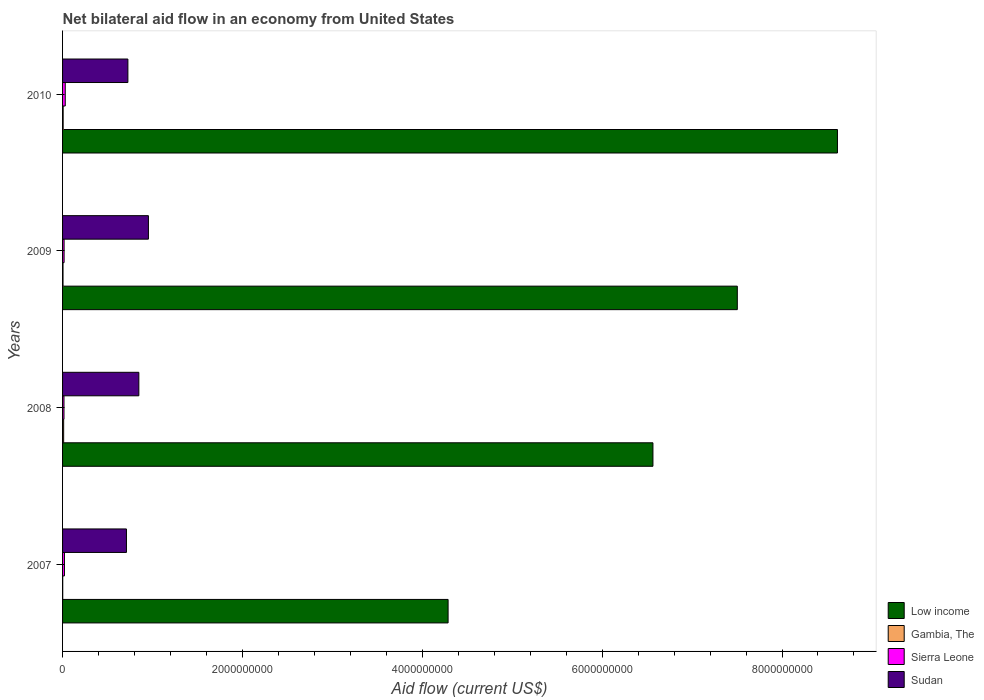Are the number of bars on each tick of the Y-axis equal?
Make the answer very short. Yes. What is the net bilateral aid flow in Sierra Leone in 2008?
Make the answer very short. 1.58e+07. Across all years, what is the maximum net bilateral aid flow in Sierra Leone?
Your answer should be very brief. 2.98e+07. Across all years, what is the minimum net bilateral aid flow in Gambia, The?
Make the answer very short. 1.66e+06. In which year was the net bilateral aid flow in Sierra Leone minimum?
Your response must be concise. 2008. What is the total net bilateral aid flow in Gambia, The in the graph?
Keep it short and to the point. 2.51e+07. What is the difference between the net bilateral aid flow in Gambia, The in 2008 and that in 2010?
Ensure brevity in your answer.  5.55e+06. What is the difference between the net bilateral aid flow in Low income in 2010 and the net bilateral aid flow in Sierra Leone in 2007?
Provide a short and direct response. 8.60e+09. What is the average net bilateral aid flow in Low income per year?
Offer a very short reply. 6.74e+09. In the year 2007, what is the difference between the net bilateral aid flow in Sierra Leone and net bilateral aid flow in Low income?
Your response must be concise. -4.27e+09. In how many years, is the net bilateral aid flow in Gambia, The greater than 6400000000 US$?
Your answer should be compact. 0. What is the ratio of the net bilateral aid flow in Sierra Leone in 2008 to that in 2010?
Make the answer very short. 0.53. Is the net bilateral aid flow in Low income in 2007 less than that in 2010?
Make the answer very short. Yes. Is the difference between the net bilateral aid flow in Sierra Leone in 2008 and 2009 greater than the difference between the net bilateral aid flow in Low income in 2008 and 2009?
Offer a very short reply. Yes. What is the difference between the highest and the second highest net bilateral aid flow in Sudan?
Keep it short and to the point. 1.06e+08. What is the difference between the highest and the lowest net bilateral aid flow in Sierra Leone?
Provide a short and direct response. 1.40e+07. In how many years, is the net bilateral aid flow in Low income greater than the average net bilateral aid flow in Low income taken over all years?
Ensure brevity in your answer.  2. Is the sum of the net bilateral aid flow in Gambia, The in 2007 and 2009 greater than the maximum net bilateral aid flow in Sierra Leone across all years?
Your response must be concise. No. What does the 3rd bar from the top in 2010 represents?
Your answer should be compact. Gambia, The. How many years are there in the graph?
Your answer should be compact. 4. What is the difference between two consecutive major ticks on the X-axis?
Provide a succinct answer. 2.00e+09. Are the values on the major ticks of X-axis written in scientific E-notation?
Make the answer very short. No. Does the graph contain any zero values?
Ensure brevity in your answer.  No. How are the legend labels stacked?
Provide a succinct answer. Vertical. What is the title of the graph?
Your response must be concise. Net bilateral aid flow in an economy from United States. What is the Aid flow (current US$) of Low income in 2007?
Provide a short and direct response. 4.29e+09. What is the Aid flow (current US$) of Gambia, The in 2007?
Give a very brief answer. 1.66e+06. What is the Aid flow (current US$) in Sierra Leone in 2007?
Give a very brief answer. 2.09e+07. What is the Aid flow (current US$) in Sudan in 2007?
Offer a terse response. 7.10e+08. What is the Aid flow (current US$) in Low income in 2008?
Offer a very short reply. 6.56e+09. What is the Aid flow (current US$) in Gambia, The in 2008?
Make the answer very short. 1.20e+07. What is the Aid flow (current US$) in Sierra Leone in 2008?
Your answer should be very brief. 1.58e+07. What is the Aid flow (current US$) in Sudan in 2008?
Provide a succinct answer. 8.48e+08. What is the Aid flow (current US$) of Low income in 2009?
Ensure brevity in your answer.  7.50e+09. What is the Aid flow (current US$) of Gambia, The in 2009?
Offer a terse response. 4.95e+06. What is the Aid flow (current US$) of Sierra Leone in 2009?
Ensure brevity in your answer.  1.70e+07. What is the Aid flow (current US$) of Sudan in 2009?
Provide a short and direct response. 9.55e+08. What is the Aid flow (current US$) in Low income in 2010?
Your response must be concise. 8.62e+09. What is the Aid flow (current US$) of Gambia, The in 2010?
Ensure brevity in your answer.  6.49e+06. What is the Aid flow (current US$) of Sierra Leone in 2010?
Provide a short and direct response. 2.98e+07. What is the Aid flow (current US$) of Sudan in 2010?
Offer a very short reply. 7.26e+08. Across all years, what is the maximum Aid flow (current US$) in Low income?
Provide a short and direct response. 8.62e+09. Across all years, what is the maximum Aid flow (current US$) in Gambia, The?
Keep it short and to the point. 1.20e+07. Across all years, what is the maximum Aid flow (current US$) of Sierra Leone?
Your response must be concise. 2.98e+07. Across all years, what is the maximum Aid flow (current US$) in Sudan?
Offer a very short reply. 9.55e+08. Across all years, what is the minimum Aid flow (current US$) of Low income?
Your answer should be very brief. 4.29e+09. Across all years, what is the minimum Aid flow (current US$) in Gambia, The?
Ensure brevity in your answer.  1.66e+06. Across all years, what is the minimum Aid flow (current US$) of Sierra Leone?
Make the answer very short. 1.58e+07. Across all years, what is the minimum Aid flow (current US$) in Sudan?
Your answer should be very brief. 7.10e+08. What is the total Aid flow (current US$) in Low income in the graph?
Ensure brevity in your answer.  2.70e+1. What is the total Aid flow (current US$) in Gambia, The in the graph?
Offer a terse response. 2.51e+07. What is the total Aid flow (current US$) of Sierra Leone in the graph?
Keep it short and to the point. 8.35e+07. What is the total Aid flow (current US$) of Sudan in the graph?
Give a very brief answer. 3.24e+09. What is the difference between the Aid flow (current US$) in Low income in 2007 and that in 2008?
Give a very brief answer. -2.28e+09. What is the difference between the Aid flow (current US$) in Gambia, The in 2007 and that in 2008?
Keep it short and to the point. -1.04e+07. What is the difference between the Aid flow (current US$) in Sierra Leone in 2007 and that in 2008?
Offer a very short reply. 5.12e+06. What is the difference between the Aid flow (current US$) in Sudan in 2007 and that in 2008?
Your answer should be very brief. -1.38e+08. What is the difference between the Aid flow (current US$) in Low income in 2007 and that in 2009?
Give a very brief answer. -3.22e+09. What is the difference between the Aid flow (current US$) in Gambia, The in 2007 and that in 2009?
Give a very brief answer. -3.29e+06. What is the difference between the Aid flow (current US$) in Sierra Leone in 2007 and that in 2009?
Provide a short and direct response. 3.91e+06. What is the difference between the Aid flow (current US$) in Sudan in 2007 and that in 2009?
Your answer should be compact. -2.44e+08. What is the difference between the Aid flow (current US$) of Low income in 2007 and that in 2010?
Provide a short and direct response. -4.33e+09. What is the difference between the Aid flow (current US$) in Gambia, The in 2007 and that in 2010?
Your answer should be very brief. -4.83e+06. What is the difference between the Aid flow (current US$) of Sierra Leone in 2007 and that in 2010?
Keep it short and to the point. -8.87e+06. What is the difference between the Aid flow (current US$) of Sudan in 2007 and that in 2010?
Keep it short and to the point. -1.59e+07. What is the difference between the Aid flow (current US$) in Low income in 2008 and that in 2009?
Keep it short and to the point. -9.38e+08. What is the difference between the Aid flow (current US$) of Gambia, The in 2008 and that in 2009?
Ensure brevity in your answer.  7.09e+06. What is the difference between the Aid flow (current US$) of Sierra Leone in 2008 and that in 2009?
Your answer should be very brief. -1.21e+06. What is the difference between the Aid flow (current US$) in Sudan in 2008 and that in 2009?
Provide a short and direct response. -1.06e+08. What is the difference between the Aid flow (current US$) in Low income in 2008 and that in 2010?
Keep it short and to the point. -2.05e+09. What is the difference between the Aid flow (current US$) of Gambia, The in 2008 and that in 2010?
Provide a succinct answer. 5.55e+06. What is the difference between the Aid flow (current US$) of Sierra Leone in 2008 and that in 2010?
Your answer should be compact. -1.40e+07. What is the difference between the Aid flow (current US$) of Sudan in 2008 and that in 2010?
Offer a terse response. 1.22e+08. What is the difference between the Aid flow (current US$) of Low income in 2009 and that in 2010?
Your answer should be very brief. -1.11e+09. What is the difference between the Aid flow (current US$) of Gambia, The in 2009 and that in 2010?
Provide a succinct answer. -1.54e+06. What is the difference between the Aid flow (current US$) in Sierra Leone in 2009 and that in 2010?
Provide a short and direct response. -1.28e+07. What is the difference between the Aid flow (current US$) in Sudan in 2009 and that in 2010?
Your answer should be compact. 2.28e+08. What is the difference between the Aid flow (current US$) of Low income in 2007 and the Aid flow (current US$) of Gambia, The in 2008?
Your response must be concise. 4.27e+09. What is the difference between the Aid flow (current US$) of Low income in 2007 and the Aid flow (current US$) of Sierra Leone in 2008?
Give a very brief answer. 4.27e+09. What is the difference between the Aid flow (current US$) of Low income in 2007 and the Aid flow (current US$) of Sudan in 2008?
Make the answer very short. 3.44e+09. What is the difference between the Aid flow (current US$) in Gambia, The in 2007 and the Aid flow (current US$) in Sierra Leone in 2008?
Your answer should be compact. -1.41e+07. What is the difference between the Aid flow (current US$) in Gambia, The in 2007 and the Aid flow (current US$) in Sudan in 2008?
Provide a succinct answer. -8.46e+08. What is the difference between the Aid flow (current US$) of Sierra Leone in 2007 and the Aid flow (current US$) of Sudan in 2008?
Keep it short and to the point. -8.27e+08. What is the difference between the Aid flow (current US$) in Low income in 2007 and the Aid flow (current US$) in Gambia, The in 2009?
Provide a succinct answer. 4.28e+09. What is the difference between the Aid flow (current US$) in Low income in 2007 and the Aid flow (current US$) in Sierra Leone in 2009?
Offer a very short reply. 4.27e+09. What is the difference between the Aid flow (current US$) of Low income in 2007 and the Aid flow (current US$) of Sudan in 2009?
Your response must be concise. 3.33e+09. What is the difference between the Aid flow (current US$) in Gambia, The in 2007 and the Aid flow (current US$) in Sierra Leone in 2009?
Make the answer very short. -1.53e+07. What is the difference between the Aid flow (current US$) in Gambia, The in 2007 and the Aid flow (current US$) in Sudan in 2009?
Offer a terse response. -9.53e+08. What is the difference between the Aid flow (current US$) in Sierra Leone in 2007 and the Aid flow (current US$) in Sudan in 2009?
Offer a terse response. -9.34e+08. What is the difference between the Aid flow (current US$) of Low income in 2007 and the Aid flow (current US$) of Gambia, The in 2010?
Your answer should be very brief. 4.28e+09. What is the difference between the Aid flow (current US$) in Low income in 2007 and the Aid flow (current US$) in Sierra Leone in 2010?
Offer a very short reply. 4.26e+09. What is the difference between the Aid flow (current US$) of Low income in 2007 and the Aid flow (current US$) of Sudan in 2010?
Your answer should be compact. 3.56e+09. What is the difference between the Aid flow (current US$) in Gambia, The in 2007 and the Aid flow (current US$) in Sierra Leone in 2010?
Your answer should be compact. -2.81e+07. What is the difference between the Aid flow (current US$) in Gambia, The in 2007 and the Aid flow (current US$) in Sudan in 2010?
Keep it short and to the point. -7.25e+08. What is the difference between the Aid flow (current US$) in Sierra Leone in 2007 and the Aid flow (current US$) in Sudan in 2010?
Provide a short and direct response. -7.05e+08. What is the difference between the Aid flow (current US$) in Low income in 2008 and the Aid flow (current US$) in Gambia, The in 2009?
Offer a very short reply. 6.56e+09. What is the difference between the Aid flow (current US$) in Low income in 2008 and the Aid flow (current US$) in Sierra Leone in 2009?
Keep it short and to the point. 6.55e+09. What is the difference between the Aid flow (current US$) of Low income in 2008 and the Aid flow (current US$) of Sudan in 2009?
Keep it short and to the point. 5.61e+09. What is the difference between the Aid flow (current US$) of Gambia, The in 2008 and the Aid flow (current US$) of Sierra Leone in 2009?
Keep it short and to the point. -4.96e+06. What is the difference between the Aid flow (current US$) of Gambia, The in 2008 and the Aid flow (current US$) of Sudan in 2009?
Keep it short and to the point. -9.43e+08. What is the difference between the Aid flow (current US$) in Sierra Leone in 2008 and the Aid flow (current US$) in Sudan in 2009?
Your answer should be very brief. -9.39e+08. What is the difference between the Aid flow (current US$) of Low income in 2008 and the Aid flow (current US$) of Gambia, The in 2010?
Your answer should be very brief. 6.56e+09. What is the difference between the Aid flow (current US$) in Low income in 2008 and the Aid flow (current US$) in Sierra Leone in 2010?
Provide a short and direct response. 6.53e+09. What is the difference between the Aid flow (current US$) in Low income in 2008 and the Aid flow (current US$) in Sudan in 2010?
Your answer should be compact. 5.84e+09. What is the difference between the Aid flow (current US$) of Gambia, The in 2008 and the Aid flow (current US$) of Sierra Leone in 2010?
Provide a succinct answer. -1.77e+07. What is the difference between the Aid flow (current US$) of Gambia, The in 2008 and the Aid flow (current US$) of Sudan in 2010?
Your response must be concise. -7.14e+08. What is the difference between the Aid flow (current US$) of Sierra Leone in 2008 and the Aid flow (current US$) of Sudan in 2010?
Give a very brief answer. -7.11e+08. What is the difference between the Aid flow (current US$) in Low income in 2009 and the Aid flow (current US$) in Gambia, The in 2010?
Keep it short and to the point. 7.50e+09. What is the difference between the Aid flow (current US$) of Low income in 2009 and the Aid flow (current US$) of Sierra Leone in 2010?
Offer a terse response. 7.47e+09. What is the difference between the Aid flow (current US$) in Low income in 2009 and the Aid flow (current US$) in Sudan in 2010?
Offer a very short reply. 6.78e+09. What is the difference between the Aid flow (current US$) of Gambia, The in 2009 and the Aid flow (current US$) of Sierra Leone in 2010?
Ensure brevity in your answer.  -2.48e+07. What is the difference between the Aid flow (current US$) in Gambia, The in 2009 and the Aid flow (current US$) in Sudan in 2010?
Offer a terse response. -7.21e+08. What is the difference between the Aid flow (current US$) in Sierra Leone in 2009 and the Aid flow (current US$) in Sudan in 2010?
Offer a very short reply. -7.09e+08. What is the average Aid flow (current US$) of Low income per year?
Provide a short and direct response. 6.74e+09. What is the average Aid flow (current US$) in Gambia, The per year?
Give a very brief answer. 6.28e+06. What is the average Aid flow (current US$) of Sierra Leone per year?
Offer a terse response. 2.09e+07. What is the average Aid flow (current US$) of Sudan per year?
Provide a short and direct response. 8.10e+08. In the year 2007, what is the difference between the Aid flow (current US$) of Low income and Aid flow (current US$) of Gambia, The?
Keep it short and to the point. 4.29e+09. In the year 2007, what is the difference between the Aid flow (current US$) in Low income and Aid flow (current US$) in Sierra Leone?
Keep it short and to the point. 4.27e+09. In the year 2007, what is the difference between the Aid flow (current US$) of Low income and Aid flow (current US$) of Sudan?
Ensure brevity in your answer.  3.58e+09. In the year 2007, what is the difference between the Aid flow (current US$) of Gambia, The and Aid flow (current US$) of Sierra Leone?
Offer a very short reply. -1.92e+07. In the year 2007, what is the difference between the Aid flow (current US$) in Gambia, The and Aid flow (current US$) in Sudan?
Provide a succinct answer. -7.09e+08. In the year 2007, what is the difference between the Aid flow (current US$) of Sierra Leone and Aid flow (current US$) of Sudan?
Your answer should be compact. -6.90e+08. In the year 2008, what is the difference between the Aid flow (current US$) in Low income and Aid flow (current US$) in Gambia, The?
Give a very brief answer. 6.55e+09. In the year 2008, what is the difference between the Aid flow (current US$) in Low income and Aid flow (current US$) in Sierra Leone?
Provide a succinct answer. 6.55e+09. In the year 2008, what is the difference between the Aid flow (current US$) in Low income and Aid flow (current US$) in Sudan?
Keep it short and to the point. 5.72e+09. In the year 2008, what is the difference between the Aid flow (current US$) in Gambia, The and Aid flow (current US$) in Sierra Leone?
Your answer should be compact. -3.75e+06. In the year 2008, what is the difference between the Aid flow (current US$) in Gambia, The and Aid flow (current US$) in Sudan?
Keep it short and to the point. -8.36e+08. In the year 2008, what is the difference between the Aid flow (current US$) in Sierra Leone and Aid flow (current US$) in Sudan?
Ensure brevity in your answer.  -8.32e+08. In the year 2009, what is the difference between the Aid flow (current US$) in Low income and Aid flow (current US$) in Gambia, The?
Provide a short and direct response. 7.50e+09. In the year 2009, what is the difference between the Aid flow (current US$) of Low income and Aid flow (current US$) of Sierra Leone?
Offer a terse response. 7.49e+09. In the year 2009, what is the difference between the Aid flow (current US$) of Low income and Aid flow (current US$) of Sudan?
Provide a short and direct response. 6.55e+09. In the year 2009, what is the difference between the Aid flow (current US$) of Gambia, The and Aid flow (current US$) of Sierra Leone?
Provide a succinct answer. -1.20e+07. In the year 2009, what is the difference between the Aid flow (current US$) in Gambia, The and Aid flow (current US$) in Sudan?
Provide a succinct answer. -9.50e+08. In the year 2009, what is the difference between the Aid flow (current US$) of Sierra Leone and Aid flow (current US$) of Sudan?
Provide a short and direct response. -9.38e+08. In the year 2010, what is the difference between the Aid flow (current US$) in Low income and Aid flow (current US$) in Gambia, The?
Offer a very short reply. 8.61e+09. In the year 2010, what is the difference between the Aid flow (current US$) in Low income and Aid flow (current US$) in Sierra Leone?
Provide a short and direct response. 8.59e+09. In the year 2010, what is the difference between the Aid flow (current US$) of Low income and Aid flow (current US$) of Sudan?
Offer a terse response. 7.89e+09. In the year 2010, what is the difference between the Aid flow (current US$) in Gambia, The and Aid flow (current US$) in Sierra Leone?
Provide a short and direct response. -2.33e+07. In the year 2010, what is the difference between the Aid flow (current US$) of Gambia, The and Aid flow (current US$) of Sudan?
Your response must be concise. -7.20e+08. In the year 2010, what is the difference between the Aid flow (current US$) in Sierra Leone and Aid flow (current US$) in Sudan?
Ensure brevity in your answer.  -6.97e+08. What is the ratio of the Aid flow (current US$) in Low income in 2007 to that in 2008?
Your answer should be compact. 0.65. What is the ratio of the Aid flow (current US$) of Gambia, The in 2007 to that in 2008?
Ensure brevity in your answer.  0.14. What is the ratio of the Aid flow (current US$) of Sierra Leone in 2007 to that in 2008?
Your answer should be very brief. 1.32. What is the ratio of the Aid flow (current US$) of Sudan in 2007 to that in 2008?
Offer a terse response. 0.84. What is the ratio of the Aid flow (current US$) of Gambia, The in 2007 to that in 2009?
Give a very brief answer. 0.34. What is the ratio of the Aid flow (current US$) of Sierra Leone in 2007 to that in 2009?
Provide a succinct answer. 1.23. What is the ratio of the Aid flow (current US$) in Sudan in 2007 to that in 2009?
Your answer should be very brief. 0.74. What is the ratio of the Aid flow (current US$) of Low income in 2007 to that in 2010?
Your answer should be very brief. 0.5. What is the ratio of the Aid flow (current US$) of Gambia, The in 2007 to that in 2010?
Offer a very short reply. 0.26. What is the ratio of the Aid flow (current US$) of Sierra Leone in 2007 to that in 2010?
Your response must be concise. 0.7. What is the ratio of the Aid flow (current US$) of Sudan in 2007 to that in 2010?
Provide a short and direct response. 0.98. What is the ratio of the Aid flow (current US$) in Gambia, The in 2008 to that in 2009?
Offer a very short reply. 2.43. What is the ratio of the Aid flow (current US$) in Sierra Leone in 2008 to that in 2009?
Offer a very short reply. 0.93. What is the ratio of the Aid flow (current US$) of Sudan in 2008 to that in 2009?
Offer a very short reply. 0.89. What is the ratio of the Aid flow (current US$) of Low income in 2008 to that in 2010?
Offer a terse response. 0.76. What is the ratio of the Aid flow (current US$) in Gambia, The in 2008 to that in 2010?
Your answer should be compact. 1.86. What is the ratio of the Aid flow (current US$) in Sierra Leone in 2008 to that in 2010?
Provide a short and direct response. 0.53. What is the ratio of the Aid flow (current US$) of Sudan in 2008 to that in 2010?
Make the answer very short. 1.17. What is the ratio of the Aid flow (current US$) of Low income in 2009 to that in 2010?
Provide a succinct answer. 0.87. What is the ratio of the Aid flow (current US$) of Gambia, The in 2009 to that in 2010?
Your response must be concise. 0.76. What is the ratio of the Aid flow (current US$) of Sierra Leone in 2009 to that in 2010?
Provide a short and direct response. 0.57. What is the ratio of the Aid flow (current US$) of Sudan in 2009 to that in 2010?
Your answer should be compact. 1.31. What is the difference between the highest and the second highest Aid flow (current US$) of Low income?
Give a very brief answer. 1.11e+09. What is the difference between the highest and the second highest Aid flow (current US$) of Gambia, The?
Keep it short and to the point. 5.55e+06. What is the difference between the highest and the second highest Aid flow (current US$) of Sierra Leone?
Make the answer very short. 8.87e+06. What is the difference between the highest and the second highest Aid flow (current US$) in Sudan?
Your answer should be very brief. 1.06e+08. What is the difference between the highest and the lowest Aid flow (current US$) in Low income?
Offer a terse response. 4.33e+09. What is the difference between the highest and the lowest Aid flow (current US$) in Gambia, The?
Give a very brief answer. 1.04e+07. What is the difference between the highest and the lowest Aid flow (current US$) of Sierra Leone?
Offer a very short reply. 1.40e+07. What is the difference between the highest and the lowest Aid flow (current US$) of Sudan?
Provide a short and direct response. 2.44e+08. 